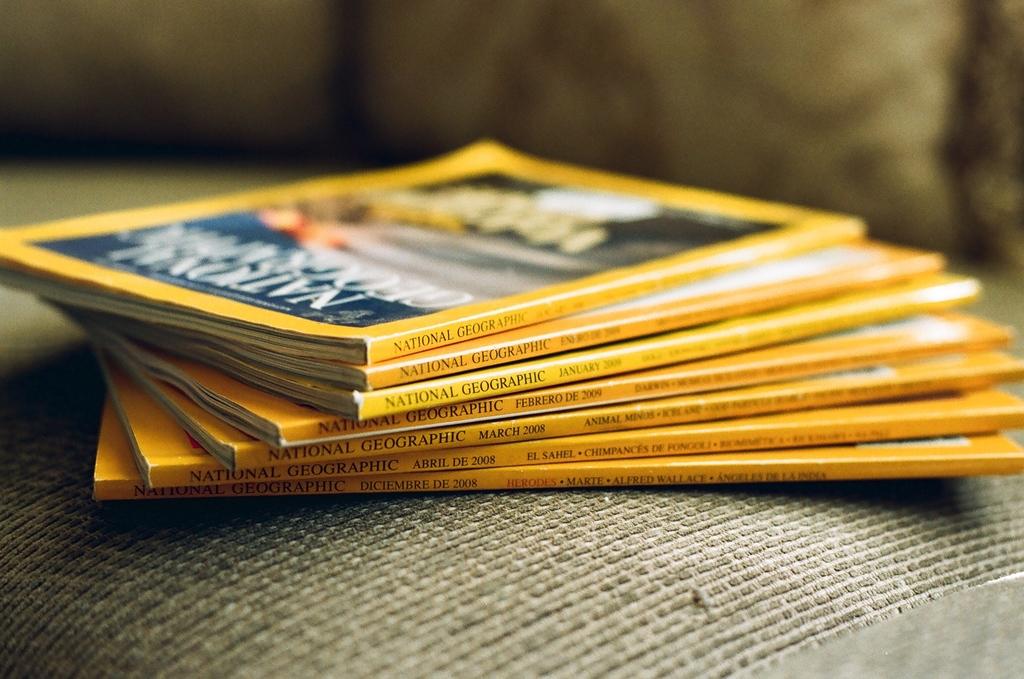What is the name of the brand of books?
Offer a very short reply. National geographic. 